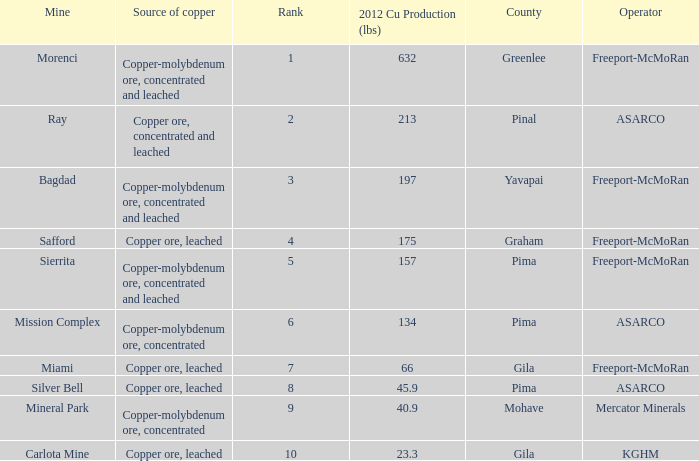Which operator has a rank of 7? Freeport-McMoRan. 